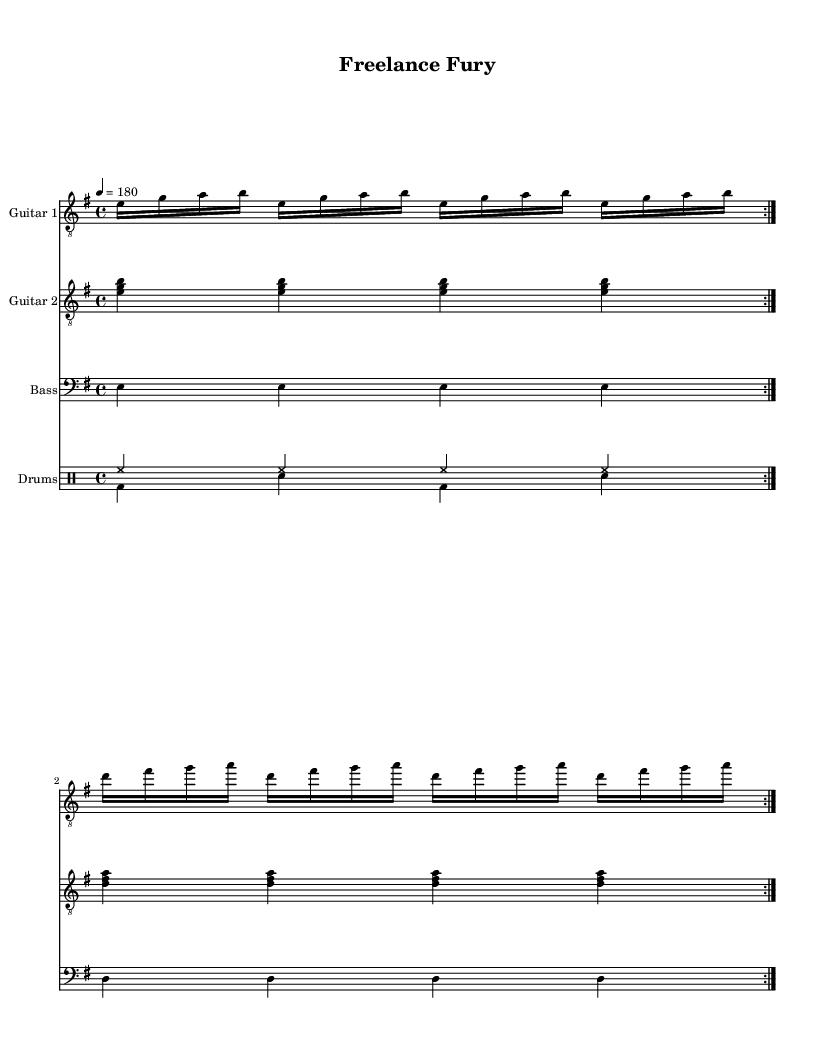What is the key signature of this music? The music is in E minor, which is indicated by the key signature showing one sharp (F#).
Answer: E minor What is the time signature of this music? The time signature is 4/4, as indicated by the notation at the beginning of the score, which tells us that there are four beats in each measure.
Answer: 4/4 What is the tempo marking for this piece? The tempo marking is 180 BPM (beats per minute), indicated at the start of the score, meaning the piece should be played at a fast pace.
Answer: 180 How many measures are repeated in this score? The score contains a repeated section indicated by "volta 2," meaning there are two repetitions of the mentioned measures, giving a total of 8 measures.
Answer: 8 What is the main instrument type featured in this music? The main instrument types featured in this music are electric guitars, bass, and drums, which are typical in metal music, focusing heavily on guitars.
Answer: Electric guitars What distinguishes the drum pattern in this piece? The drum pattern features a combination of hi-hat and bass drum, utilizing standard rock beats with a heavy emphasis on downbeats, which is characteristic of aggressive metal.
Answer: Hi-hat and bass drum What is the texture of the guitar parts in this score? The guitar parts show a combination of rhythm and lead elements, where Guitar 1 carries the melody while Guitar 2 provides harmonic support, typical in aggressive metal styles.
Answer: Rhythm and lead elements 